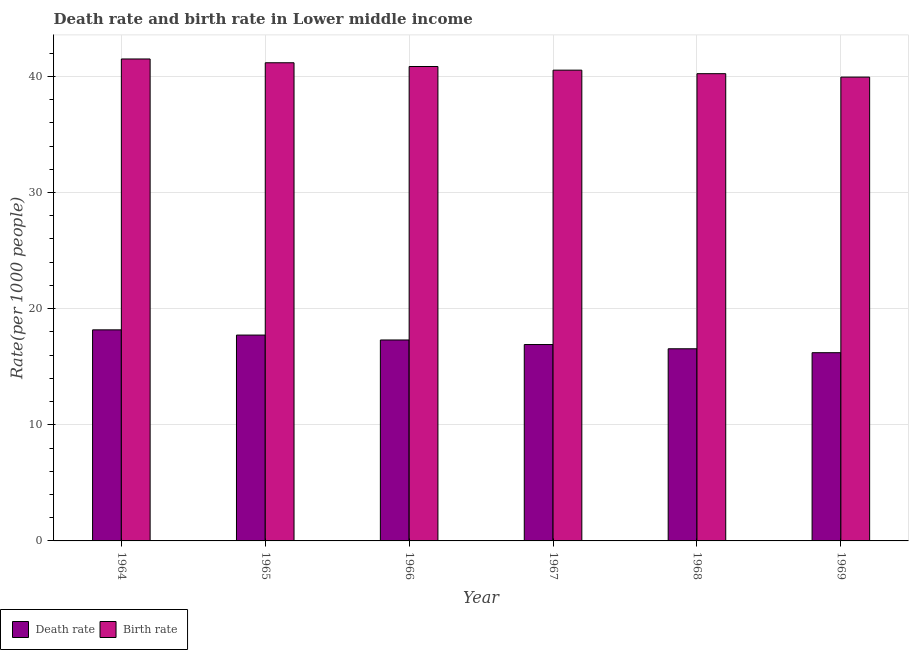How many groups of bars are there?
Keep it short and to the point. 6. Are the number of bars per tick equal to the number of legend labels?
Your answer should be very brief. Yes. Are the number of bars on each tick of the X-axis equal?
Keep it short and to the point. Yes. How many bars are there on the 5th tick from the left?
Provide a short and direct response. 2. How many bars are there on the 1st tick from the right?
Give a very brief answer. 2. What is the label of the 3rd group of bars from the left?
Offer a terse response. 1966. In how many cases, is the number of bars for a given year not equal to the number of legend labels?
Your answer should be compact. 0. What is the birth rate in 1964?
Provide a short and direct response. 41.5. Across all years, what is the maximum death rate?
Ensure brevity in your answer.  18.17. Across all years, what is the minimum death rate?
Ensure brevity in your answer.  16.21. In which year was the birth rate maximum?
Keep it short and to the point. 1964. In which year was the death rate minimum?
Give a very brief answer. 1969. What is the total birth rate in the graph?
Make the answer very short. 244.21. What is the difference between the birth rate in 1966 and that in 1969?
Provide a succinct answer. 0.91. What is the difference between the birth rate in 1965 and the death rate in 1964?
Keep it short and to the point. -0.33. What is the average birth rate per year?
Offer a very short reply. 40.7. What is the ratio of the death rate in 1966 to that in 1968?
Provide a short and direct response. 1.05. Is the death rate in 1967 less than that in 1968?
Offer a very short reply. No. Is the difference between the birth rate in 1964 and 1967 greater than the difference between the death rate in 1964 and 1967?
Your answer should be very brief. No. What is the difference between the highest and the second highest death rate?
Your response must be concise. 0.45. What is the difference between the highest and the lowest death rate?
Keep it short and to the point. 1.97. What does the 2nd bar from the left in 1965 represents?
Offer a very short reply. Birth rate. What does the 1st bar from the right in 1969 represents?
Make the answer very short. Birth rate. How many years are there in the graph?
Keep it short and to the point. 6. What is the difference between two consecutive major ticks on the Y-axis?
Your answer should be compact. 10. Are the values on the major ticks of Y-axis written in scientific E-notation?
Offer a terse response. No. Does the graph contain grids?
Ensure brevity in your answer.  Yes. How many legend labels are there?
Provide a short and direct response. 2. How are the legend labels stacked?
Provide a short and direct response. Horizontal. What is the title of the graph?
Your answer should be very brief. Death rate and birth rate in Lower middle income. Does "From World Bank" appear as one of the legend labels in the graph?
Provide a short and direct response. No. What is the label or title of the X-axis?
Your answer should be very brief. Year. What is the label or title of the Y-axis?
Offer a terse response. Rate(per 1000 people). What is the Rate(per 1000 people) of Death rate in 1964?
Provide a short and direct response. 18.17. What is the Rate(per 1000 people) in Birth rate in 1964?
Ensure brevity in your answer.  41.5. What is the Rate(per 1000 people) in Death rate in 1965?
Your answer should be very brief. 17.72. What is the Rate(per 1000 people) in Birth rate in 1965?
Offer a terse response. 41.17. What is the Rate(per 1000 people) in Death rate in 1966?
Provide a short and direct response. 17.3. What is the Rate(per 1000 people) in Birth rate in 1966?
Make the answer very short. 40.85. What is the Rate(per 1000 people) in Death rate in 1967?
Make the answer very short. 16.91. What is the Rate(per 1000 people) in Birth rate in 1967?
Keep it short and to the point. 40.53. What is the Rate(per 1000 people) of Death rate in 1968?
Your response must be concise. 16.54. What is the Rate(per 1000 people) in Birth rate in 1968?
Keep it short and to the point. 40.23. What is the Rate(per 1000 people) in Death rate in 1969?
Make the answer very short. 16.21. What is the Rate(per 1000 people) of Birth rate in 1969?
Ensure brevity in your answer.  39.94. Across all years, what is the maximum Rate(per 1000 people) of Death rate?
Keep it short and to the point. 18.17. Across all years, what is the maximum Rate(per 1000 people) of Birth rate?
Provide a short and direct response. 41.5. Across all years, what is the minimum Rate(per 1000 people) in Death rate?
Give a very brief answer. 16.21. Across all years, what is the minimum Rate(per 1000 people) of Birth rate?
Ensure brevity in your answer.  39.94. What is the total Rate(per 1000 people) of Death rate in the graph?
Make the answer very short. 102.86. What is the total Rate(per 1000 people) in Birth rate in the graph?
Your answer should be compact. 244.21. What is the difference between the Rate(per 1000 people) in Death rate in 1964 and that in 1965?
Your response must be concise. 0.45. What is the difference between the Rate(per 1000 people) in Birth rate in 1964 and that in 1965?
Provide a succinct answer. 0.33. What is the difference between the Rate(per 1000 people) in Death rate in 1964 and that in 1966?
Keep it short and to the point. 0.87. What is the difference between the Rate(per 1000 people) in Birth rate in 1964 and that in 1966?
Offer a very short reply. 0.65. What is the difference between the Rate(per 1000 people) in Death rate in 1964 and that in 1967?
Your answer should be compact. 1.26. What is the difference between the Rate(per 1000 people) of Birth rate in 1964 and that in 1967?
Keep it short and to the point. 0.96. What is the difference between the Rate(per 1000 people) in Death rate in 1964 and that in 1968?
Your response must be concise. 1.63. What is the difference between the Rate(per 1000 people) in Birth rate in 1964 and that in 1968?
Your answer should be compact. 1.27. What is the difference between the Rate(per 1000 people) in Death rate in 1964 and that in 1969?
Your answer should be compact. 1.97. What is the difference between the Rate(per 1000 people) of Birth rate in 1964 and that in 1969?
Your answer should be very brief. 1.56. What is the difference between the Rate(per 1000 people) in Death rate in 1965 and that in 1966?
Your answer should be compact. 0.42. What is the difference between the Rate(per 1000 people) in Birth rate in 1965 and that in 1966?
Make the answer very short. 0.32. What is the difference between the Rate(per 1000 people) of Death rate in 1965 and that in 1967?
Offer a terse response. 0.82. What is the difference between the Rate(per 1000 people) in Birth rate in 1965 and that in 1967?
Ensure brevity in your answer.  0.64. What is the difference between the Rate(per 1000 people) in Death rate in 1965 and that in 1968?
Your answer should be compact. 1.18. What is the difference between the Rate(per 1000 people) of Birth rate in 1965 and that in 1968?
Provide a succinct answer. 0.94. What is the difference between the Rate(per 1000 people) of Death rate in 1965 and that in 1969?
Offer a terse response. 1.52. What is the difference between the Rate(per 1000 people) of Birth rate in 1965 and that in 1969?
Ensure brevity in your answer.  1.23. What is the difference between the Rate(per 1000 people) in Death rate in 1966 and that in 1967?
Ensure brevity in your answer.  0.39. What is the difference between the Rate(per 1000 people) of Birth rate in 1966 and that in 1967?
Provide a short and direct response. 0.31. What is the difference between the Rate(per 1000 people) of Death rate in 1966 and that in 1968?
Ensure brevity in your answer.  0.76. What is the difference between the Rate(per 1000 people) in Birth rate in 1966 and that in 1968?
Keep it short and to the point. 0.62. What is the difference between the Rate(per 1000 people) in Death rate in 1966 and that in 1969?
Make the answer very short. 1.1. What is the difference between the Rate(per 1000 people) in Birth rate in 1966 and that in 1969?
Offer a terse response. 0.91. What is the difference between the Rate(per 1000 people) in Death rate in 1967 and that in 1968?
Ensure brevity in your answer.  0.36. What is the difference between the Rate(per 1000 people) of Birth rate in 1967 and that in 1968?
Give a very brief answer. 0.3. What is the difference between the Rate(per 1000 people) in Death rate in 1967 and that in 1969?
Your response must be concise. 0.7. What is the difference between the Rate(per 1000 people) of Birth rate in 1967 and that in 1969?
Provide a short and direct response. 0.6. What is the difference between the Rate(per 1000 people) of Death rate in 1968 and that in 1969?
Your answer should be very brief. 0.34. What is the difference between the Rate(per 1000 people) of Birth rate in 1968 and that in 1969?
Offer a terse response. 0.29. What is the difference between the Rate(per 1000 people) in Death rate in 1964 and the Rate(per 1000 people) in Birth rate in 1965?
Make the answer very short. -23. What is the difference between the Rate(per 1000 people) in Death rate in 1964 and the Rate(per 1000 people) in Birth rate in 1966?
Offer a very short reply. -22.67. What is the difference between the Rate(per 1000 people) in Death rate in 1964 and the Rate(per 1000 people) in Birth rate in 1967?
Offer a very short reply. -22.36. What is the difference between the Rate(per 1000 people) in Death rate in 1964 and the Rate(per 1000 people) in Birth rate in 1968?
Your response must be concise. -22.06. What is the difference between the Rate(per 1000 people) in Death rate in 1964 and the Rate(per 1000 people) in Birth rate in 1969?
Your answer should be compact. -21.76. What is the difference between the Rate(per 1000 people) of Death rate in 1965 and the Rate(per 1000 people) of Birth rate in 1966?
Your answer should be very brief. -23.12. What is the difference between the Rate(per 1000 people) of Death rate in 1965 and the Rate(per 1000 people) of Birth rate in 1967?
Keep it short and to the point. -22.81. What is the difference between the Rate(per 1000 people) in Death rate in 1965 and the Rate(per 1000 people) in Birth rate in 1968?
Keep it short and to the point. -22.51. What is the difference between the Rate(per 1000 people) of Death rate in 1965 and the Rate(per 1000 people) of Birth rate in 1969?
Provide a succinct answer. -22.21. What is the difference between the Rate(per 1000 people) in Death rate in 1966 and the Rate(per 1000 people) in Birth rate in 1967?
Ensure brevity in your answer.  -23.23. What is the difference between the Rate(per 1000 people) of Death rate in 1966 and the Rate(per 1000 people) of Birth rate in 1968?
Your answer should be very brief. -22.93. What is the difference between the Rate(per 1000 people) of Death rate in 1966 and the Rate(per 1000 people) of Birth rate in 1969?
Provide a succinct answer. -22.63. What is the difference between the Rate(per 1000 people) of Death rate in 1967 and the Rate(per 1000 people) of Birth rate in 1968?
Provide a succinct answer. -23.32. What is the difference between the Rate(per 1000 people) in Death rate in 1967 and the Rate(per 1000 people) in Birth rate in 1969?
Your response must be concise. -23.03. What is the difference between the Rate(per 1000 people) in Death rate in 1968 and the Rate(per 1000 people) in Birth rate in 1969?
Your answer should be compact. -23.39. What is the average Rate(per 1000 people) of Death rate per year?
Offer a very short reply. 17.14. What is the average Rate(per 1000 people) of Birth rate per year?
Offer a terse response. 40.7. In the year 1964, what is the difference between the Rate(per 1000 people) of Death rate and Rate(per 1000 people) of Birth rate?
Your answer should be compact. -23.32. In the year 1965, what is the difference between the Rate(per 1000 people) of Death rate and Rate(per 1000 people) of Birth rate?
Provide a short and direct response. -23.45. In the year 1966, what is the difference between the Rate(per 1000 people) of Death rate and Rate(per 1000 people) of Birth rate?
Your response must be concise. -23.55. In the year 1967, what is the difference between the Rate(per 1000 people) of Death rate and Rate(per 1000 people) of Birth rate?
Provide a succinct answer. -23.63. In the year 1968, what is the difference between the Rate(per 1000 people) in Death rate and Rate(per 1000 people) in Birth rate?
Your response must be concise. -23.69. In the year 1969, what is the difference between the Rate(per 1000 people) in Death rate and Rate(per 1000 people) in Birth rate?
Make the answer very short. -23.73. What is the ratio of the Rate(per 1000 people) in Death rate in 1964 to that in 1965?
Offer a very short reply. 1.03. What is the ratio of the Rate(per 1000 people) in Birth rate in 1964 to that in 1965?
Your response must be concise. 1.01. What is the ratio of the Rate(per 1000 people) in Death rate in 1964 to that in 1966?
Provide a succinct answer. 1.05. What is the ratio of the Rate(per 1000 people) of Birth rate in 1964 to that in 1966?
Ensure brevity in your answer.  1.02. What is the ratio of the Rate(per 1000 people) of Death rate in 1964 to that in 1967?
Make the answer very short. 1.07. What is the ratio of the Rate(per 1000 people) in Birth rate in 1964 to that in 1967?
Give a very brief answer. 1.02. What is the ratio of the Rate(per 1000 people) in Death rate in 1964 to that in 1968?
Offer a terse response. 1.1. What is the ratio of the Rate(per 1000 people) of Birth rate in 1964 to that in 1968?
Provide a short and direct response. 1.03. What is the ratio of the Rate(per 1000 people) in Death rate in 1964 to that in 1969?
Your answer should be compact. 1.12. What is the ratio of the Rate(per 1000 people) of Birth rate in 1964 to that in 1969?
Give a very brief answer. 1.04. What is the ratio of the Rate(per 1000 people) of Death rate in 1965 to that in 1966?
Provide a succinct answer. 1.02. What is the ratio of the Rate(per 1000 people) in Birth rate in 1965 to that in 1966?
Your answer should be compact. 1.01. What is the ratio of the Rate(per 1000 people) in Death rate in 1965 to that in 1967?
Ensure brevity in your answer.  1.05. What is the ratio of the Rate(per 1000 people) in Birth rate in 1965 to that in 1967?
Make the answer very short. 1.02. What is the ratio of the Rate(per 1000 people) in Death rate in 1965 to that in 1968?
Provide a short and direct response. 1.07. What is the ratio of the Rate(per 1000 people) of Birth rate in 1965 to that in 1968?
Make the answer very short. 1.02. What is the ratio of the Rate(per 1000 people) of Death rate in 1965 to that in 1969?
Ensure brevity in your answer.  1.09. What is the ratio of the Rate(per 1000 people) in Birth rate in 1965 to that in 1969?
Offer a very short reply. 1.03. What is the ratio of the Rate(per 1000 people) of Death rate in 1966 to that in 1967?
Make the answer very short. 1.02. What is the ratio of the Rate(per 1000 people) in Birth rate in 1966 to that in 1967?
Ensure brevity in your answer.  1.01. What is the ratio of the Rate(per 1000 people) of Death rate in 1966 to that in 1968?
Your answer should be very brief. 1.05. What is the ratio of the Rate(per 1000 people) of Birth rate in 1966 to that in 1968?
Your response must be concise. 1.02. What is the ratio of the Rate(per 1000 people) in Death rate in 1966 to that in 1969?
Your response must be concise. 1.07. What is the ratio of the Rate(per 1000 people) in Birth rate in 1966 to that in 1969?
Keep it short and to the point. 1.02. What is the ratio of the Rate(per 1000 people) of Birth rate in 1967 to that in 1968?
Your answer should be compact. 1.01. What is the ratio of the Rate(per 1000 people) in Death rate in 1967 to that in 1969?
Your response must be concise. 1.04. What is the ratio of the Rate(per 1000 people) of Death rate in 1968 to that in 1969?
Give a very brief answer. 1.02. What is the ratio of the Rate(per 1000 people) in Birth rate in 1968 to that in 1969?
Your answer should be compact. 1.01. What is the difference between the highest and the second highest Rate(per 1000 people) of Death rate?
Ensure brevity in your answer.  0.45. What is the difference between the highest and the second highest Rate(per 1000 people) of Birth rate?
Provide a succinct answer. 0.33. What is the difference between the highest and the lowest Rate(per 1000 people) of Death rate?
Keep it short and to the point. 1.97. What is the difference between the highest and the lowest Rate(per 1000 people) in Birth rate?
Ensure brevity in your answer.  1.56. 